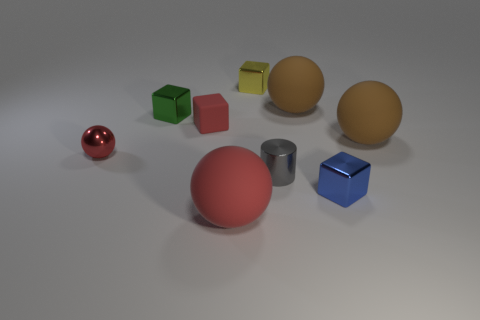There is a rubber object on the right side of the small blue cube; what is its shape?
Make the answer very short. Sphere. Are the green object and the blue cube made of the same material?
Make the answer very short. Yes. There is a small red object that is the same shape as the blue object; what material is it?
Make the answer very short. Rubber. Are there fewer tiny green metallic cubes on the right side of the red rubber block than large purple matte things?
Ensure brevity in your answer.  No. How many large brown matte spheres are behind the tiny yellow metal thing?
Your answer should be very brief. 0. There is a brown thing that is in front of the green block; does it have the same shape as the small matte object that is behind the big red object?
Give a very brief answer. No. What shape is the rubber object that is to the left of the cylinder and behind the metallic ball?
Give a very brief answer. Cube. There is a cylinder that is the same material as the tiny yellow cube; what size is it?
Provide a succinct answer. Small. Is the number of yellow matte cylinders less than the number of large rubber spheres?
Your answer should be very brief. Yes. There is a red object behind the brown matte ball that is right of the block in front of the small gray thing; what is it made of?
Offer a terse response. Rubber. 